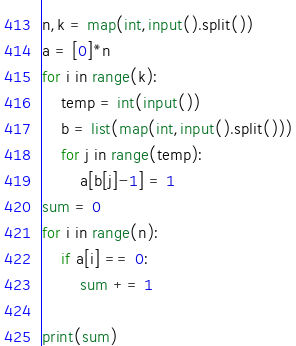<code> <loc_0><loc_0><loc_500><loc_500><_Python_>n,k = map(int,input().split())
a = [0]*n
for i in range(k):
    temp = int(input())
    b = list(map(int,input().split()))
    for j in range(temp):
        a[b[j]-1] = 1
sum = 0
for i in range(n):
    if a[i] == 0:
        sum += 1

print(sum)</code> 